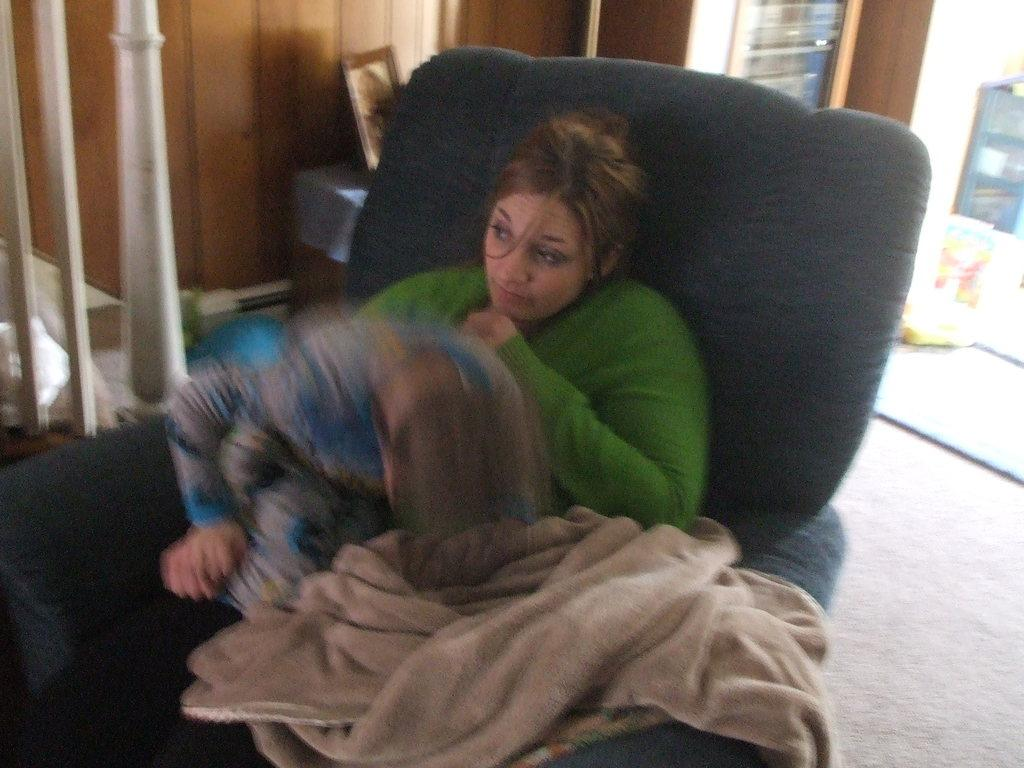What is the main subject of the image? The main subject of the image is a person sitting on a chair. What is the person doing while sitting on the chair? The person has a kid on her. What can be seen on the left side of the image? There is a picture frame on a table at the left side of the image. What type of work is the person doing in the image? There is no indication of work being done in the image; the person is simply sitting on a chair with a kid on her. Can you see a receipt on the table in the image? There is no mention of a receipt in the image; only a picture frame is mentioned on the table. 